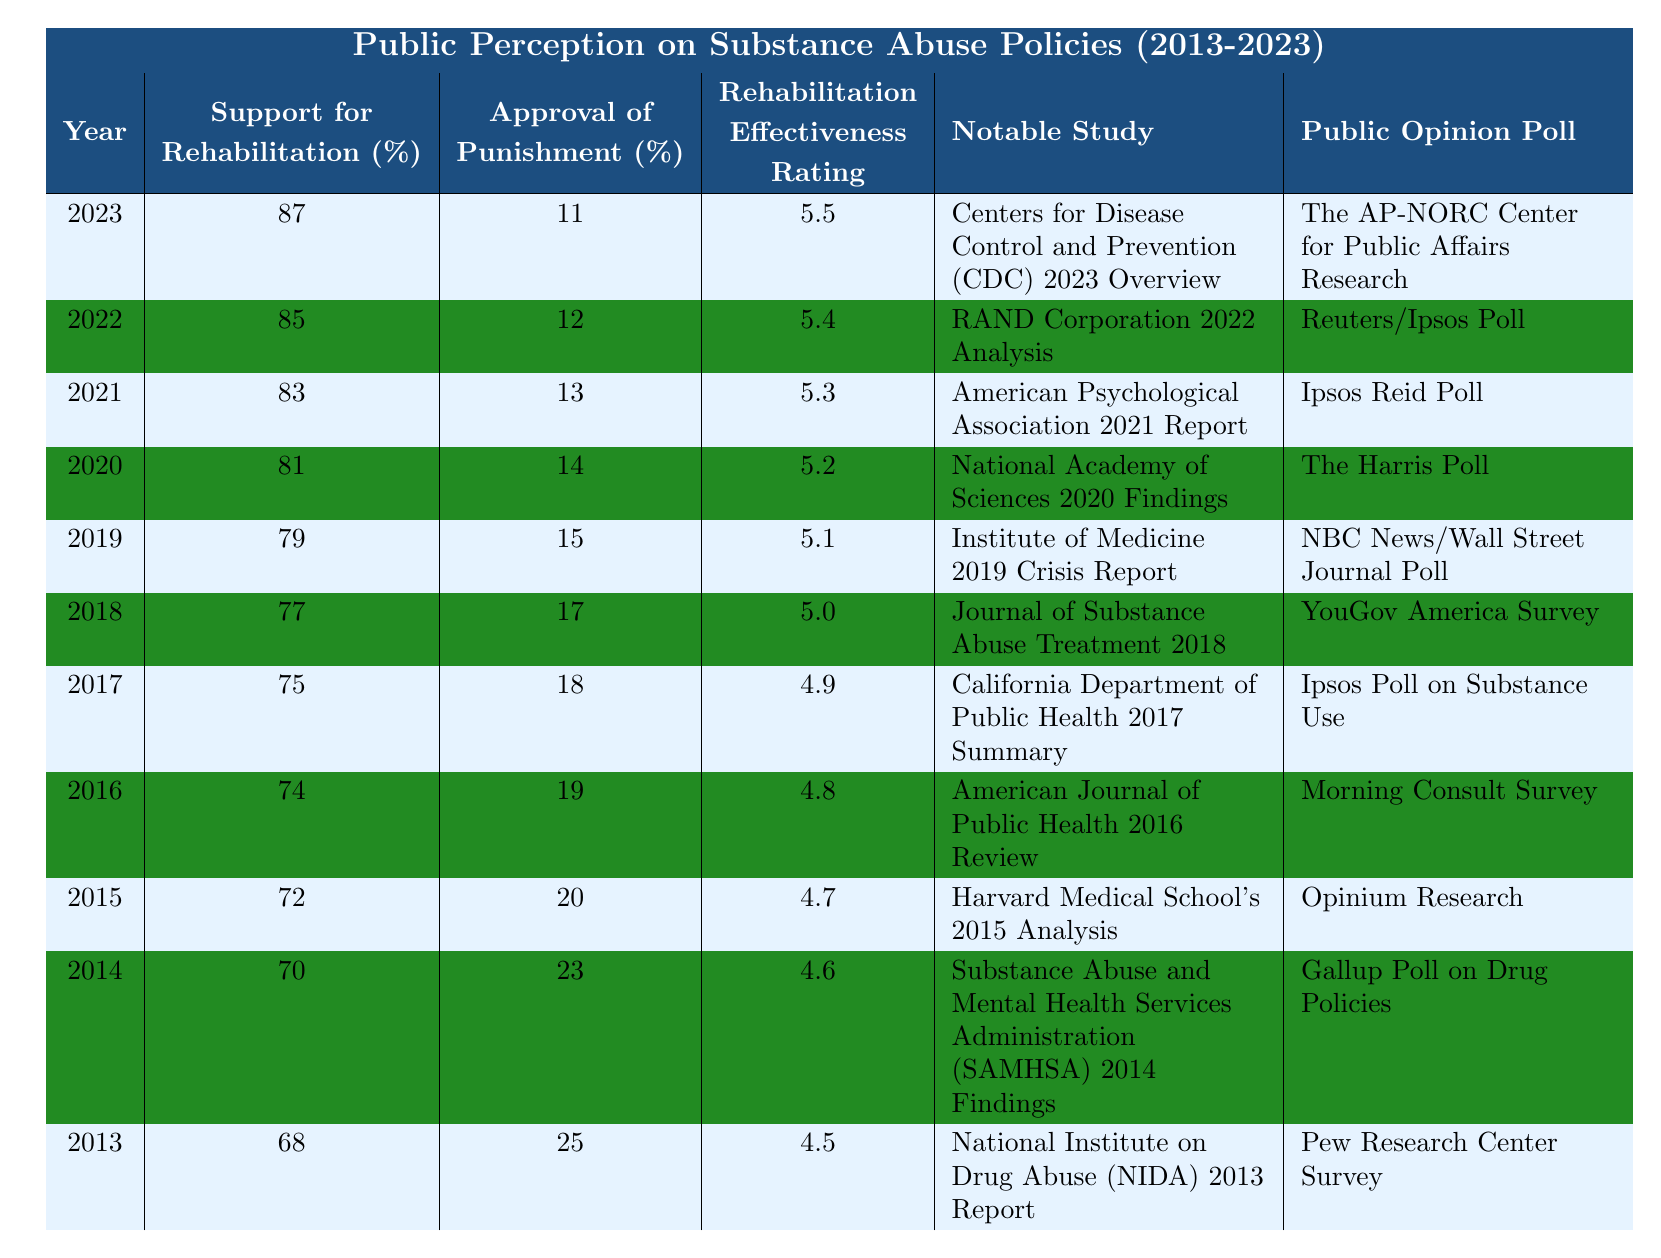What was the support for rehabilitation in 2023? In the row for the year 2023, the percentage support for rehabilitation is listed as 87%.
Answer: 87% What was the approval percentage for punishment in 2014? In the row for the year 2014, the approval percentage for punishment is 23%.
Answer: 23% What was the rehabilitation effectiveness rating in 2019? The rehabilitation effectiveness rating for the year 2019 is shown as 5.1.
Answer: 5.1 What was the notable study referenced in 2021? The notable study for the year 2021 is the American Psychological Association 2021 Report.
Answer: American Psychological Association 2021 Report In which year did support for rehabilitation first exceed 80%? Support for rehabilitation first exceeded 80% in the year 2020, with 81% support.
Answer: 2020 What is the difference in the percentage of approval for punishment between 2023 and 2013? In 2023, the percentage of approval for punishment is 11%, and in 2013 it was 25%. The difference is 25% - 11% = 14%.
Answer: 14% What was the trend in the effectiveness rating for rehabilitation from 2013 to 2023? The effectiveness rating increased from 4.5 in 2013 to 5.5 in 2023, indicating a positive trend.
Answer: Positive trend What was the average percentage support for rehabilitation over the years from 2013 to 2023? Adding the support percentages from each year and dividing by the number of years gives: (68 + 70 + 72 + 74 + 75 + 77 + 79 + 81 + 83 + 85 + 87) / 11 = 78.09, which rounds to approximately 78%.
Answer: 78% Is the public opinion trend towards rehabilitation support increasing or decreasing? The public opinion trend shows an increase in support for rehabilitation from 68% in 2013 to 87% in 2023, which is an increase.
Answer: Increasing Which year had the highest percentage of support for rehabilitation? The year with the highest percentage of support for rehabilitation is 2023 with 87%.
Answer: 2023 